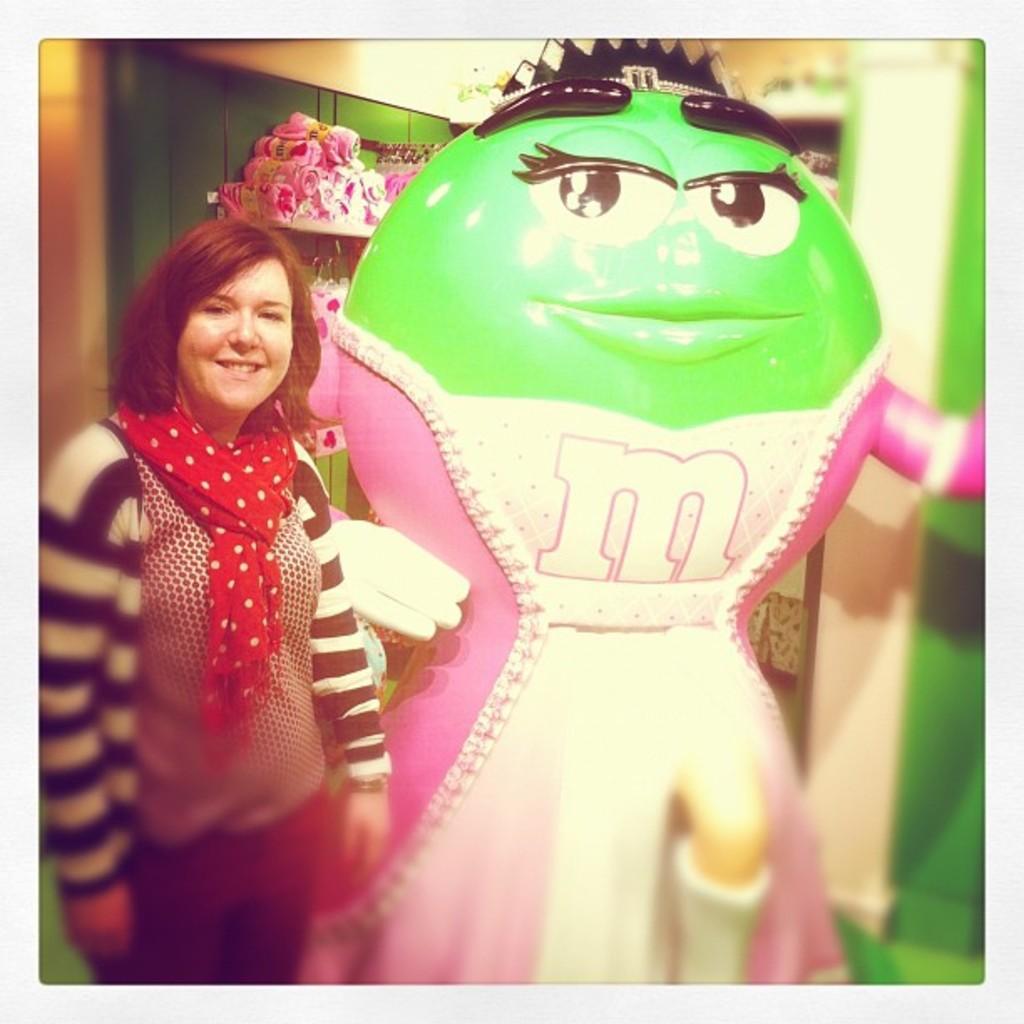Describe this image in one or two sentences. In this image, we can see a woman standing beside a doll statue and smiling. In the background, we can see few things are placed on the shelf. On the right side of the image, there is a blur view. 